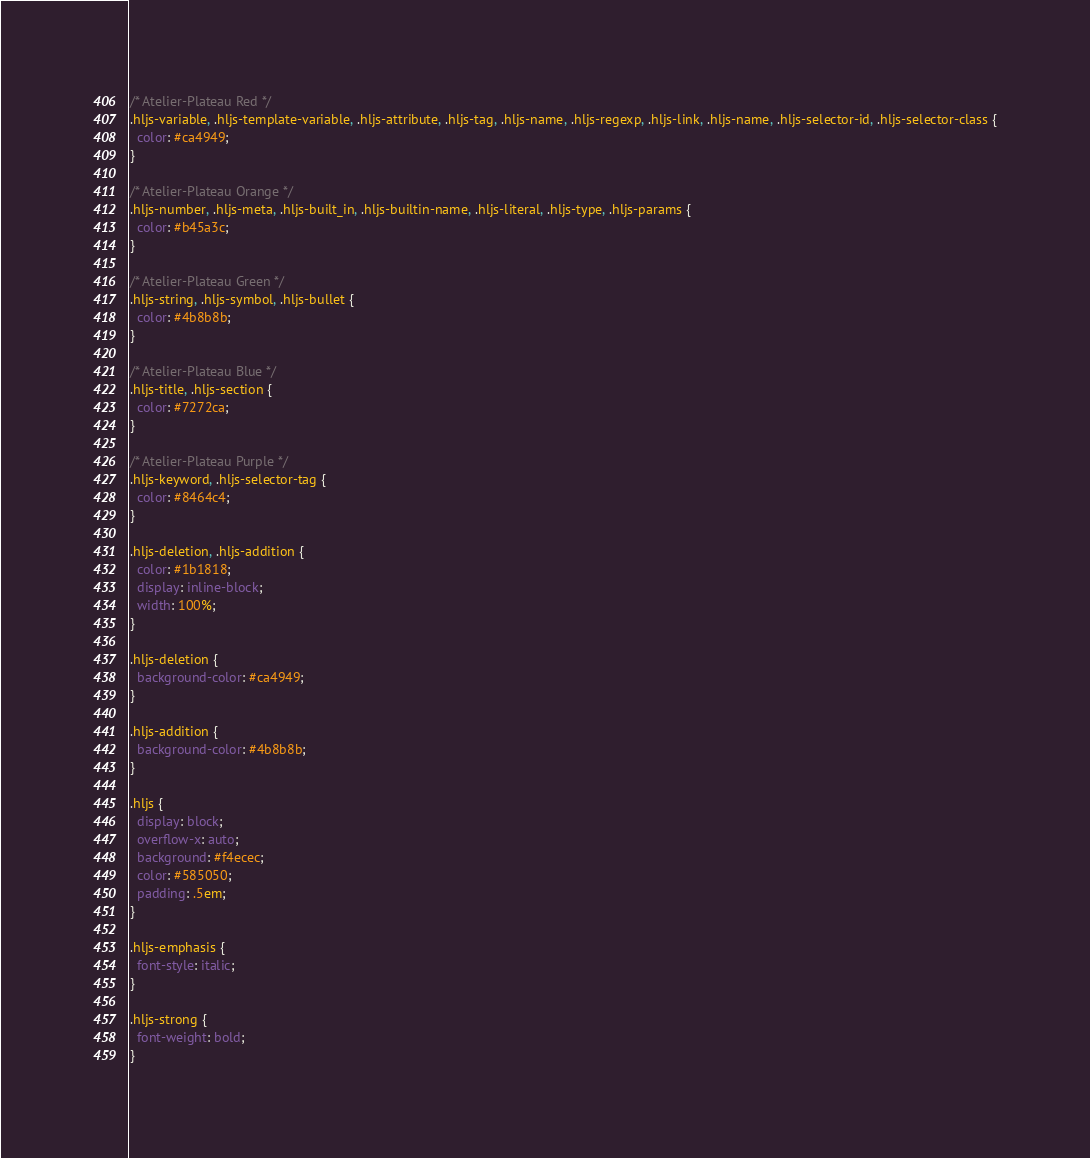Convert code to text. <code><loc_0><loc_0><loc_500><loc_500><_CSS_>
/* Atelier-Plateau Red */
.hljs-variable, .hljs-template-variable, .hljs-attribute, .hljs-tag, .hljs-name, .hljs-regexp, .hljs-link, .hljs-name, .hljs-selector-id, .hljs-selector-class {
  color: #ca4949;
}

/* Atelier-Plateau Orange */
.hljs-number, .hljs-meta, .hljs-built_in, .hljs-builtin-name, .hljs-literal, .hljs-type, .hljs-params {
  color: #b45a3c;
}

/* Atelier-Plateau Green */
.hljs-string, .hljs-symbol, .hljs-bullet {
  color: #4b8b8b;
}

/* Atelier-Plateau Blue */
.hljs-title, .hljs-section {
  color: #7272ca;
}

/* Atelier-Plateau Purple */
.hljs-keyword, .hljs-selector-tag {
  color: #8464c4;
}

.hljs-deletion, .hljs-addition {
  color: #1b1818;
  display: inline-block;
  width: 100%;
}

.hljs-deletion {
  background-color: #ca4949;
}

.hljs-addition {
  background-color: #4b8b8b;
}

.hljs {
  display: block;
  overflow-x: auto;
  background: #f4ecec;
  color: #585050;
  padding: .5em;
}

.hljs-emphasis {
  font-style: italic;
}

.hljs-strong {
  font-weight: bold;
}
</code> 